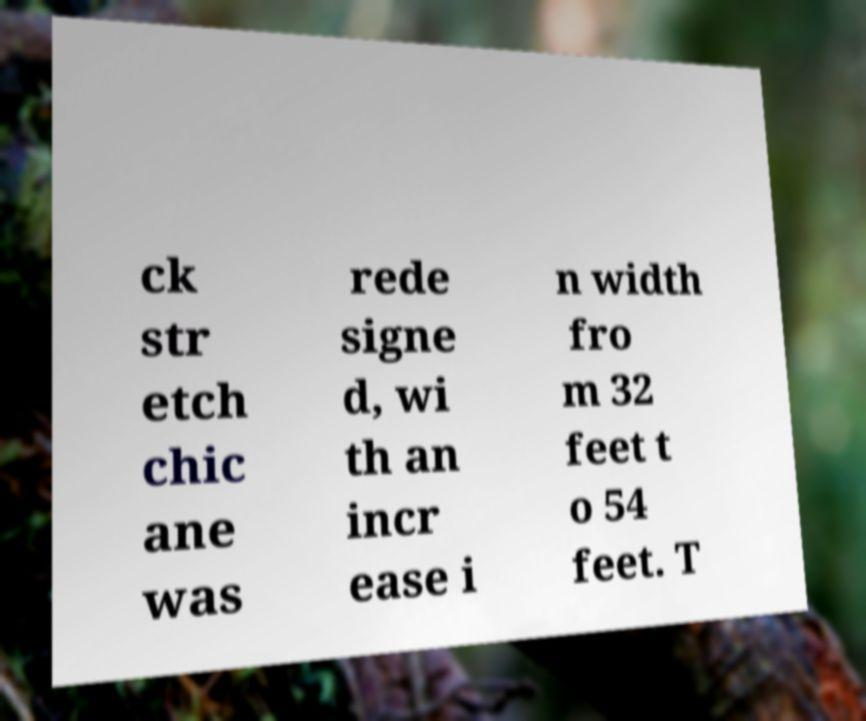I need the written content from this picture converted into text. Can you do that? ck str etch chic ane was rede signe d, wi th an incr ease i n width fro m 32 feet t o 54 feet. T 